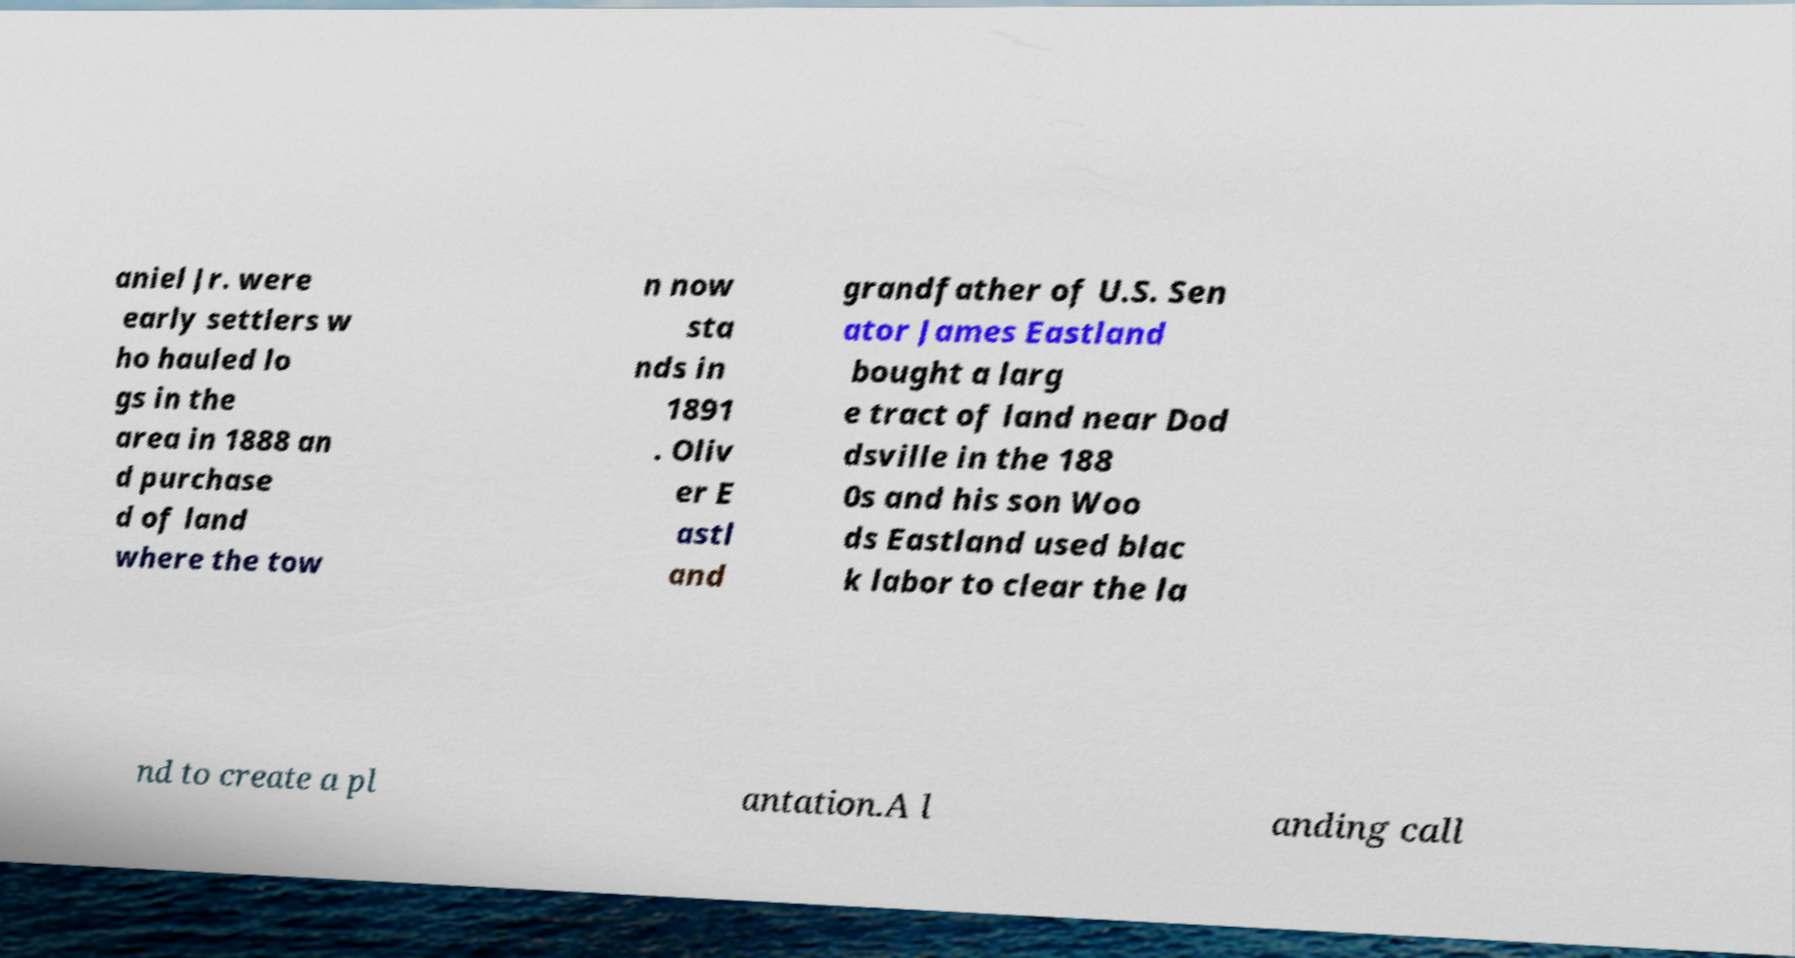What messages or text are displayed in this image? I need them in a readable, typed format. aniel Jr. were early settlers w ho hauled lo gs in the area in 1888 an d purchase d of land where the tow n now sta nds in 1891 . Oliv er E astl and grandfather of U.S. Sen ator James Eastland bought a larg e tract of land near Dod dsville in the 188 0s and his son Woo ds Eastland used blac k labor to clear the la nd to create a pl antation.A l anding call 